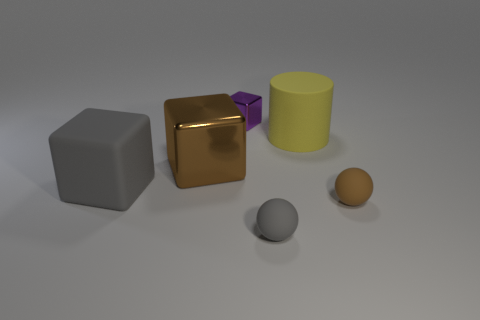Does the brown thing that is on the left side of the tiny brown rubber thing have the same material as the brown thing in front of the large metallic block?
Your answer should be very brief. No. There is a metal thing that is left of the purple metallic object; what is its size?
Your answer should be very brief. Large. The yellow object has what size?
Your answer should be very brief. Large. There is a brown object in front of the gray thing that is behind the brown thing on the right side of the brown metallic object; what is its size?
Offer a terse response. Small. Are there any tiny blue things that have the same material as the cylinder?
Ensure brevity in your answer.  No. What is the shape of the tiny brown object?
Keep it short and to the point. Sphere. There is a cylinder that is made of the same material as the large gray block; what color is it?
Your answer should be compact. Yellow. What number of purple things are cylinders or large objects?
Your answer should be compact. 0. Are there more large red metal spheres than yellow objects?
Offer a very short reply. No. How many objects are either brown shiny things in front of the cylinder or brown things that are right of the big shiny cube?
Keep it short and to the point. 2. 